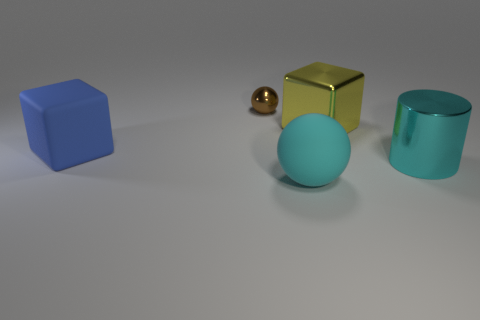What number of other things are made of the same material as the large cyan cylinder?
Offer a very short reply. 2. What shape is the metal object that is in front of the small metal thing and behind the matte cube?
Offer a terse response. Cube. What is the color of the cube that is the same material as the cyan cylinder?
Keep it short and to the point. Yellow. Is the number of cyan shiny objects on the left side of the tiny ball the same as the number of purple shiny objects?
Keep it short and to the point. Yes. There is a rubber thing that is the same size as the cyan matte sphere; what shape is it?
Provide a short and direct response. Cube. How many other objects are the same shape as the blue object?
Provide a short and direct response. 1. There is a cyan rubber thing; does it have the same size as the cube that is behind the large blue object?
Keep it short and to the point. Yes. What number of things are metallic objects that are in front of the large blue object or big blue rubber objects?
Offer a very short reply. 2. The matte thing that is in front of the big blue block has what shape?
Your answer should be compact. Sphere. Are there an equal number of blocks that are behind the tiny brown object and blue rubber blocks that are behind the large shiny block?
Provide a short and direct response. Yes. 